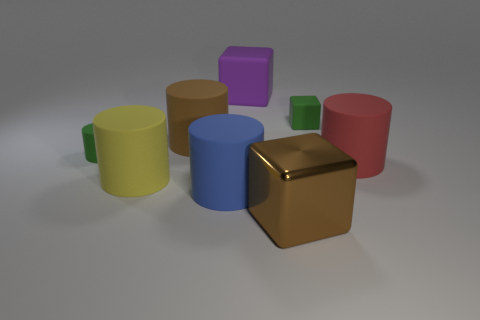What is the color of the large matte cylinder that is behind the green cylinder? The large matte cylinder positioned behind the green cylinder appears to have a deep brown hue with a soft, non-reflective surface which indicates its matte texture. 